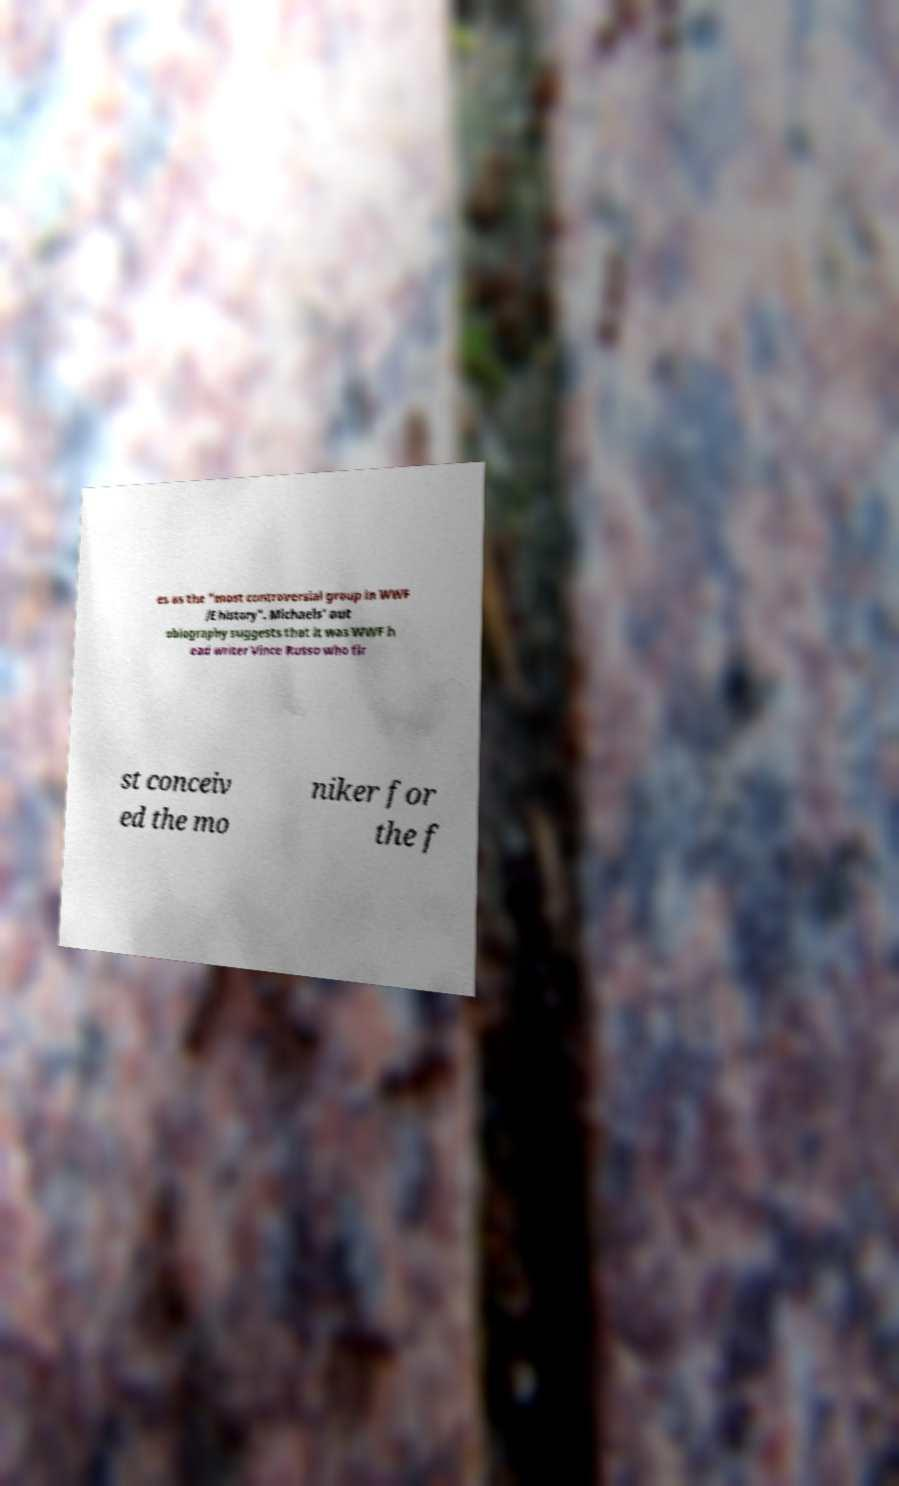There's text embedded in this image that I need extracted. Can you transcribe it verbatim? es as the "most controversial group in WWF /E history". Michaels' aut obiography suggests that it was WWF h ead writer Vince Russo who fir st conceiv ed the mo niker for the f 